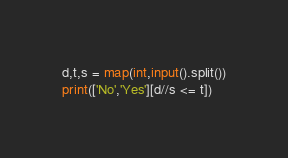<code> <loc_0><loc_0><loc_500><loc_500><_Python_>d,t,s = map(int,input().split())
print(['No','Yes'][d//s <= t])</code> 